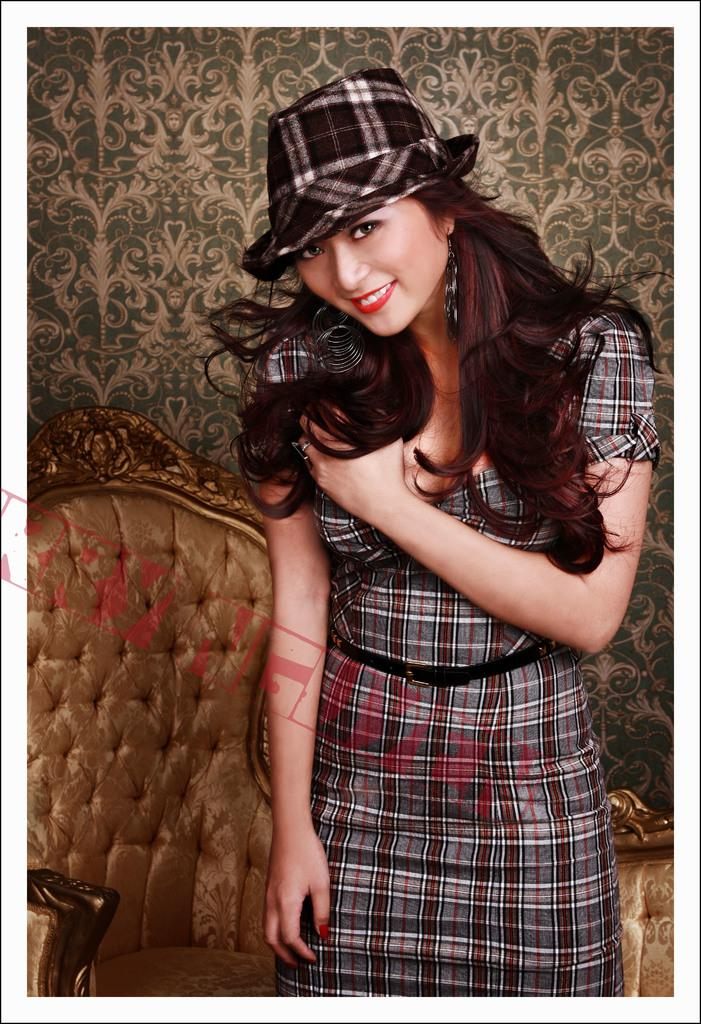Who is the main subject in the image? There is a girl in the image. What is the girl wearing on her head? The girl is wearing a cap. What type of furniture can be seen in the image? There is a sofa visible in the image. Is there an umbrella being held by the girl in the image? No, there is no umbrella present in the image. How many men are visible in the image? There are no men visible in the image; only the girl is present. 